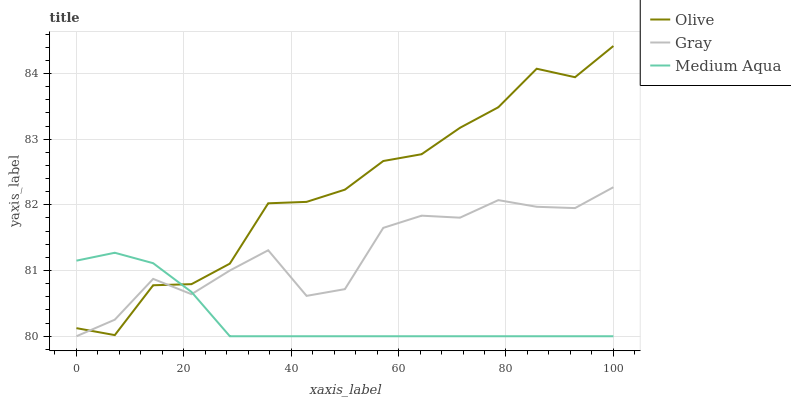Does Medium Aqua have the minimum area under the curve?
Answer yes or no. Yes. Does Olive have the maximum area under the curve?
Answer yes or no. Yes. Does Gray have the minimum area under the curve?
Answer yes or no. No. Does Gray have the maximum area under the curve?
Answer yes or no. No. Is Medium Aqua the smoothest?
Answer yes or no. Yes. Is Gray the roughest?
Answer yes or no. Yes. Is Gray the smoothest?
Answer yes or no. No. Is Medium Aqua the roughest?
Answer yes or no. No. Does Olive have the highest value?
Answer yes or no. Yes. Does Gray have the highest value?
Answer yes or no. No. Does Medium Aqua intersect Gray?
Answer yes or no. Yes. Is Medium Aqua less than Gray?
Answer yes or no. No. Is Medium Aqua greater than Gray?
Answer yes or no. No. 